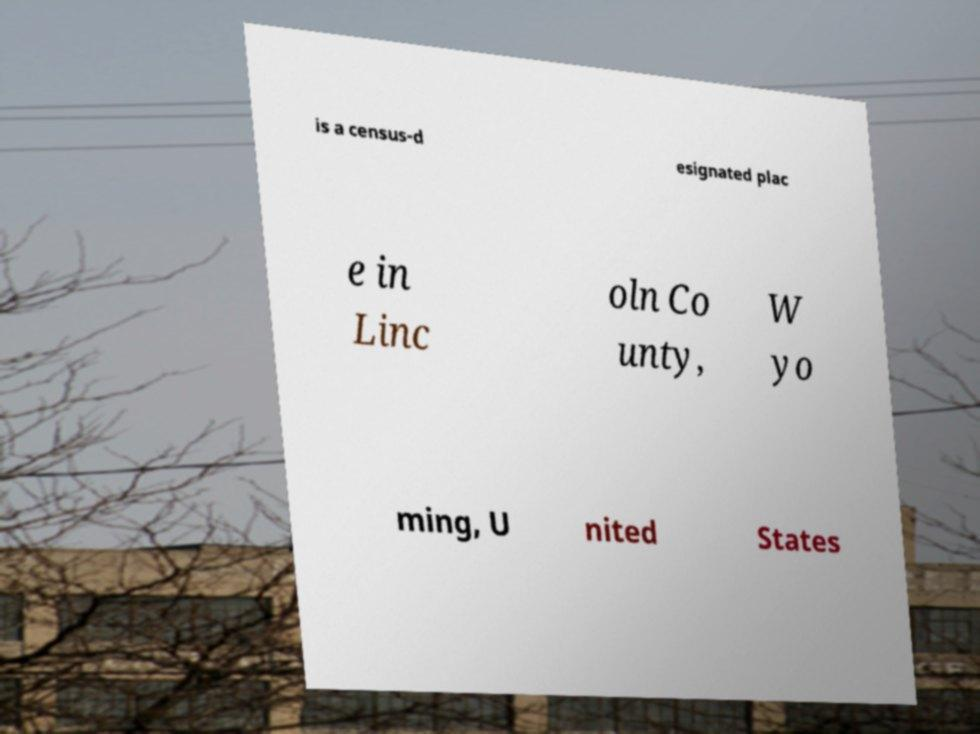Please read and relay the text visible in this image. What does it say? is a census-d esignated plac e in Linc oln Co unty, W yo ming, U nited States 